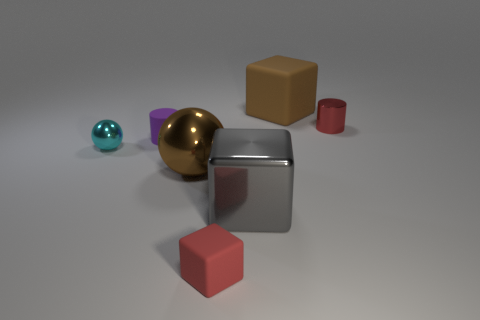Add 2 brown cubes. How many objects exist? 9 Subtract all spheres. How many objects are left? 5 Add 7 large brown matte objects. How many large brown matte objects are left? 8 Add 2 tiny red rubber balls. How many tiny red rubber balls exist? 2 Subtract 1 purple cylinders. How many objects are left? 6 Subtract all rubber cubes. Subtract all small red rubber things. How many objects are left? 4 